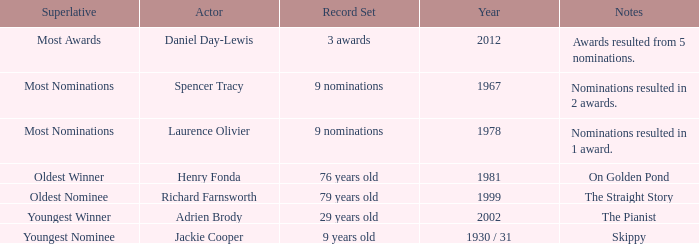What year was the the youngest nominee a winner? 1930 / 31. 